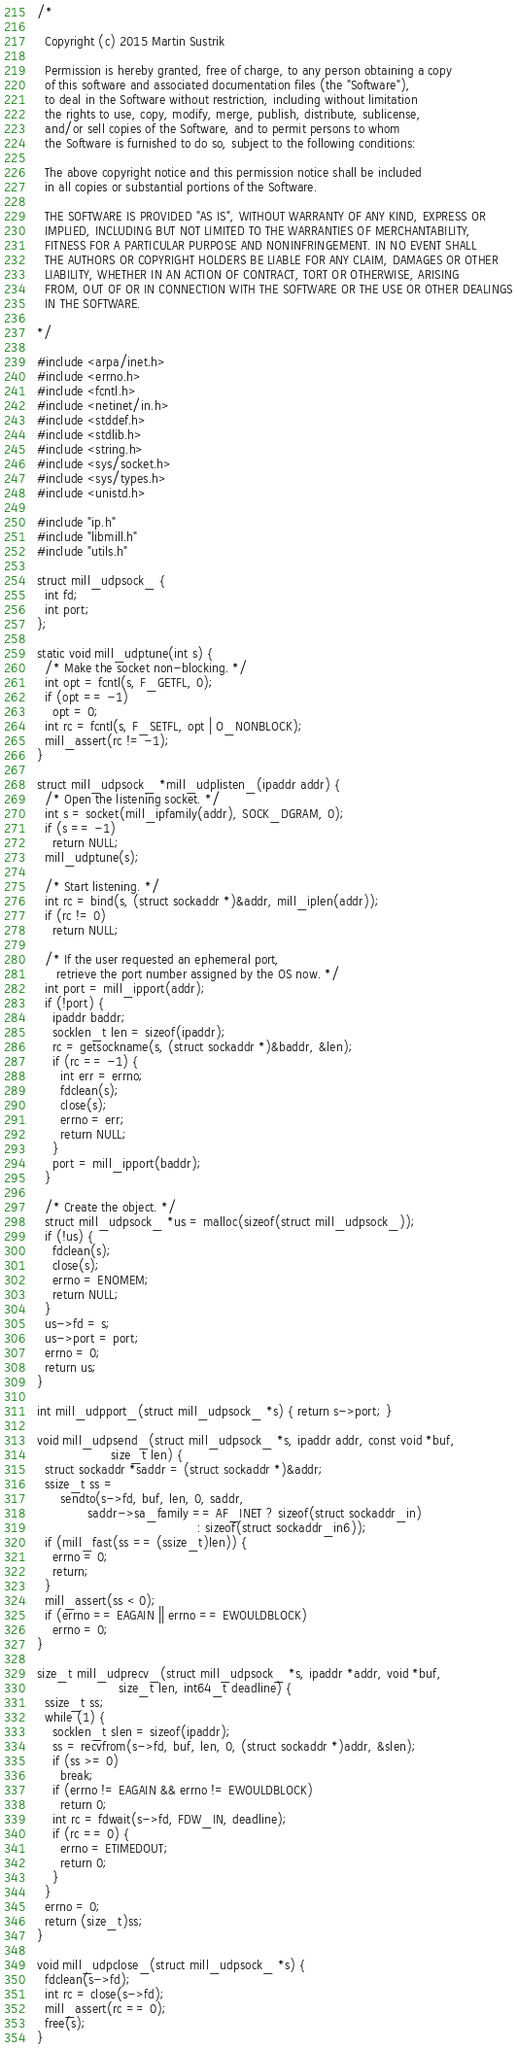Convert code to text. <code><loc_0><loc_0><loc_500><loc_500><_C_>/*

  Copyright (c) 2015 Martin Sustrik

  Permission is hereby granted, free of charge, to any person obtaining a copy
  of this software and associated documentation files (the "Software"),
  to deal in the Software without restriction, including without limitation
  the rights to use, copy, modify, merge, publish, distribute, sublicense,
  and/or sell copies of the Software, and to permit persons to whom
  the Software is furnished to do so, subject to the following conditions:

  The above copyright notice and this permission notice shall be included
  in all copies or substantial portions of the Software.

  THE SOFTWARE IS PROVIDED "AS IS", WITHOUT WARRANTY OF ANY KIND, EXPRESS OR
  IMPLIED, INCLUDING BUT NOT LIMITED TO THE WARRANTIES OF MERCHANTABILITY,
  FITNESS FOR A PARTICULAR PURPOSE AND NONINFRINGEMENT. IN NO EVENT SHALL
  THE AUTHORS OR COPYRIGHT HOLDERS BE LIABLE FOR ANY CLAIM, DAMAGES OR OTHER
  LIABILITY, WHETHER IN AN ACTION OF CONTRACT, TORT OR OTHERWISE, ARISING
  FROM, OUT OF OR IN CONNECTION WITH THE SOFTWARE OR THE USE OR OTHER DEALINGS
  IN THE SOFTWARE.

*/

#include <arpa/inet.h>
#include <errno.h>
#include <fcntl.h>
#include <netinet/in.h>
#include <stddef.h>
#include <stdlib.h>
#include <string.h>
#include <sys/socket.h>
#include <sys/types.h>
#include <unistd.h>

#include "ip.h"
#include "libmill.h"
#include "utils.h"

struct mill_udpsock_ {
  int fd;
  int port;
};

static void mill_udptune(int s) {
  /* Make the socket non-blocking. */
  int opt = fcntl(s, F_GETFL, 0);
  if (opt == -1)
    opt = 0;
  int rc = fcntl(s, F_SETFL, opt | O_NONBLOCK);
  mill_assert(rc != -1);
}

struct mill_udpsock_ *mill_udplisten_(ipaddr addr) {
  /* Open the listening socket. */
  int s = socket(mill_ipfamily(addr), SOCK_DGRAM, 0);
  if (s == -1)
    return NULL;
  mill_udptune(s);

  /* Start listening. */
  int rc = bind(s, (struct sockaddr *)&addr, mill_iplen(addr));
  if (rc != 0)
    return NULL;

  /* If the user requested an ephemeral port,
     retrieve the port number assigned by the OS now. */
  int port = mill_ipport(addr);
  if (!port) {
    ipaddr baddr;
    socklen_t len = sizeof(ipaddr);
    rc = getsockname(s, (struct sockaddr *)&baddr, &len);
    if (rc == -1) {
      int err = errno;
      fdclean(s);
      close(s);
      errno = err;
      return NULL;
    }
    port = mill_ipport(baddr);
  }

  /* Create the object. */
  struct mill_udpsock_ *us = malloc(sizeof(struct mill_udpsock_));
  if (!us) {
    fdclean(s);
    close(s);
    errno = ENOMEM;
    return NULL;
  }
  us->fd = s;
  us->port = port;
  errno = 0;
  return us;
}

int mill_udpport_(struct mill_udpsock_ *s) { return s->port; }

void mill_udpsend_(struct mill_udpsock_ *s, ipaddr addr, const void *buf,
                   size_t len) {
  struct sockaddr *saddr = (struct sockaddr *)&addr;
  ssize_t ss =
      sendto(s->fd, buf, len, 0, saddr,
             saddr->sa_family == AF_INET ? sizeof(struct sockaddr_in)
                                         : sizeof(struct sockaddr_in6));
  if (mill_fast(ss == (ssize_t)len)) {
    errno = 0;
    return;
  }
  mill_assert(ss < 0);
  if (errno == EAGAIN || errno == EWOULDBLOCK)
    errno = 0;
}

size_t mill_udprecv_(struct mill_udpsock_ *s, ipaddr *addr, void *buf,
                     size_t len, int64_t deadline) {
  ssize_t ss;
  while (1) {
    socklen_t slen = sizeof(ipaddr);
    ss = recvfrom(s->fd, buf, len, 0, (struct sockaddr *)addr, &slen);
    if (ss >= 0)
      break;
    if (errno != EAGAIN && errno != EWOULDBLOCK)
      return 0;
    int rc = fdwait(s->fd, FDW_IN, deadline);
    if (rc == 0) {
      errno = ETIMEDOUT;
      return 0;
    }
  }
  errno = 0;
  return (size_t)ss;
}

void mill_udpclose_(struct mill_udpsock_ *s) {
  fdclean(s->fd);
  int rc = close(s->fd);
  mill_assert(rc == 0);
  free(s);
}
</code> 